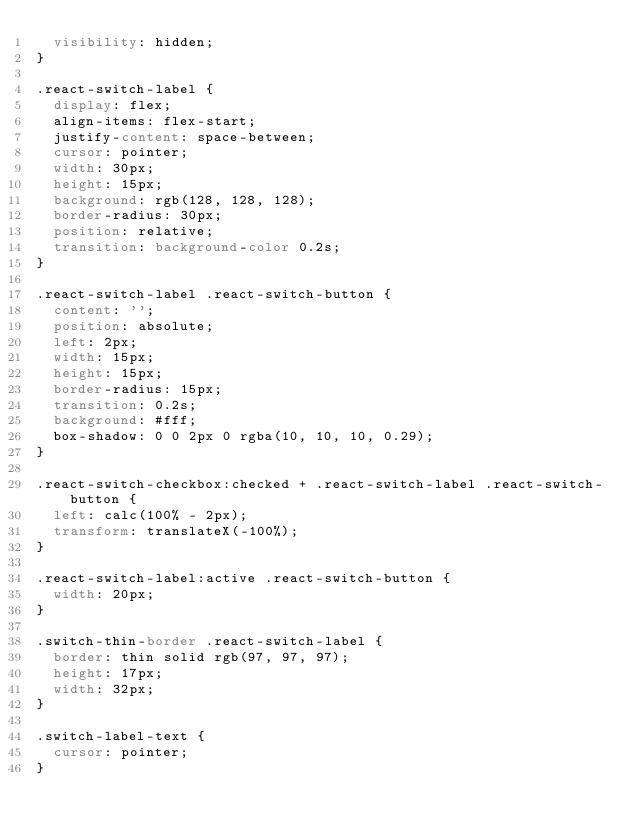<code> <loc_0><loc_0><loc_500><loc_500><_CSS_>  visibility: hidden;
}

.react-switch-label {
  display: flex;
  align-items: flex-start;
  justify-content: space-between;
  cursor: pointer;
  width: 30px;
  height: 15px;
  background: rgb(128, 128, 128);
  border-radius: 30px;
  position: relative;
  transition: background-color 0.2s;
}

.react-switch-label .react-switch-button {
  content: '';
  position: absolute;
  left: 2px;
  width: 15px;
  height: 15px;
  border-radius: 15px;
  transition: 0.2s;
  background: #fff;
  box-shadow: 0 0 2px 0 rgba(10, 10, 10, 0.29);
}

.react-switch-checkbox:checked + .react-switch-label .react-switch-button {
  left: calc(100% - 2px);
  transform: translateX(-100%);
}

.react-switch-label:active .react-switch-button {
  width: 20px;
}

.switch-thin-border .react-switch-label {
  border: thin solid rgb(97, 97, 97);
  height: 17px;
  width: 32px;
}

.switch-label-text {
  cursor: pointer;
}
</code> 